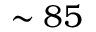Convert formula to latex. <formula><loc_0><loc_0><loc_500><loc_500>\sim 8 5</formula> 